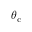<formula> <loc_0><loc_0><loc_500><loc_500>\theta _ { c }</formula> 